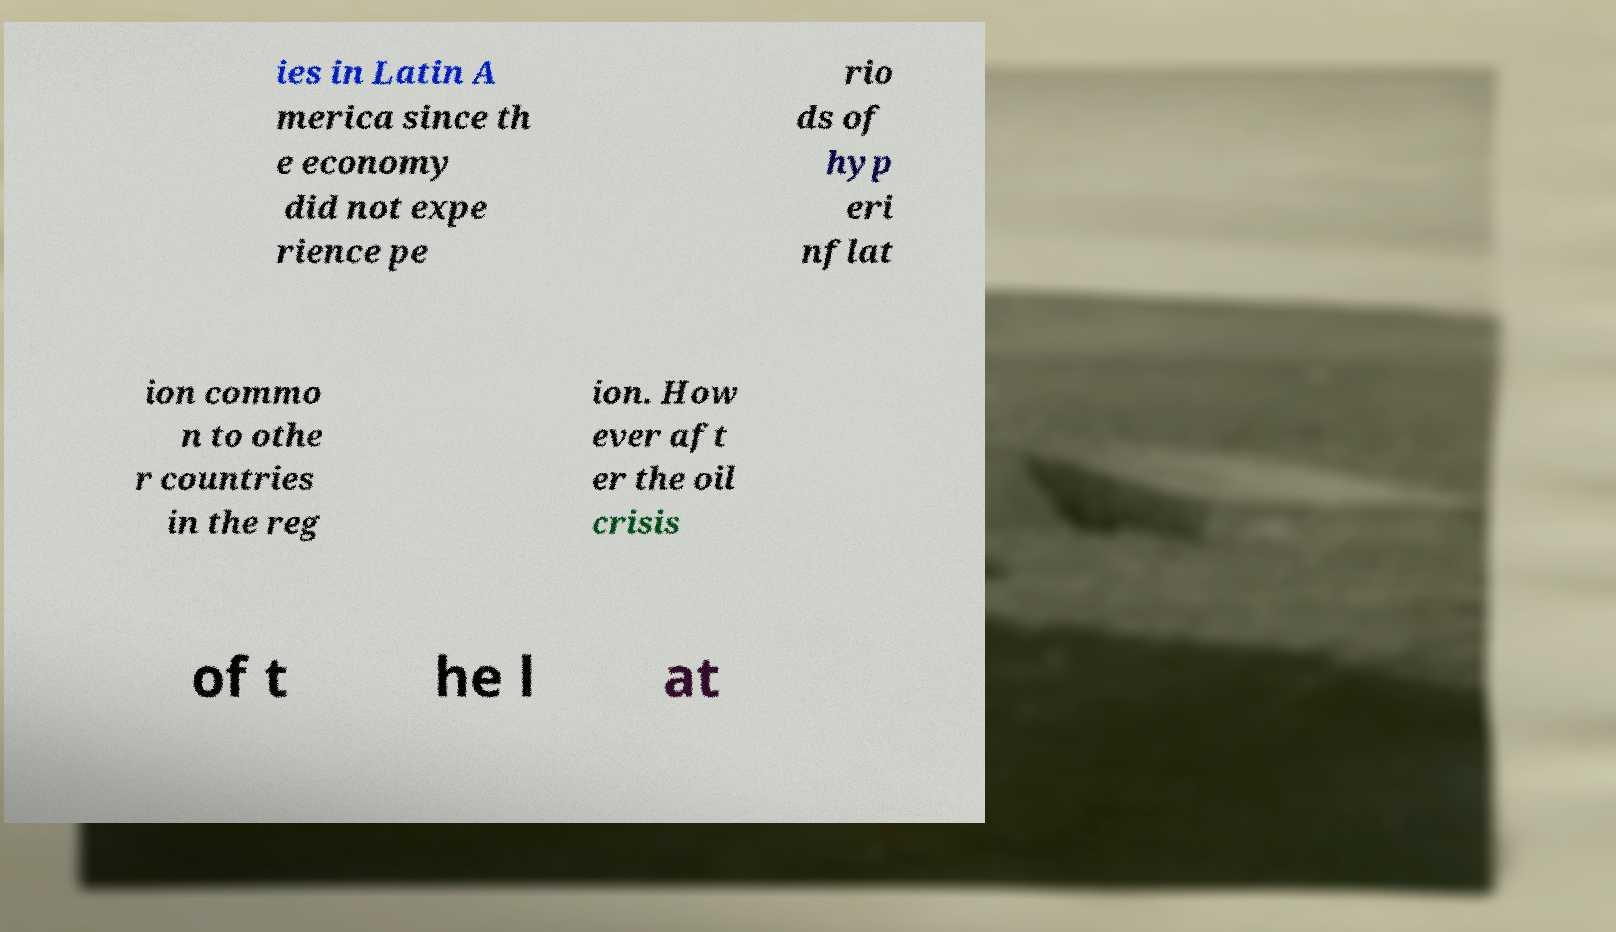For documentation purposes, I need the text within this image transcribed. Could you provide that? ies in Latin A merica since th e economy did not expe rience pe rio ds of hyp eri nflat ion commo n to othe r countries in the reg ion. How ever aft er the oil crisis of t he l at 